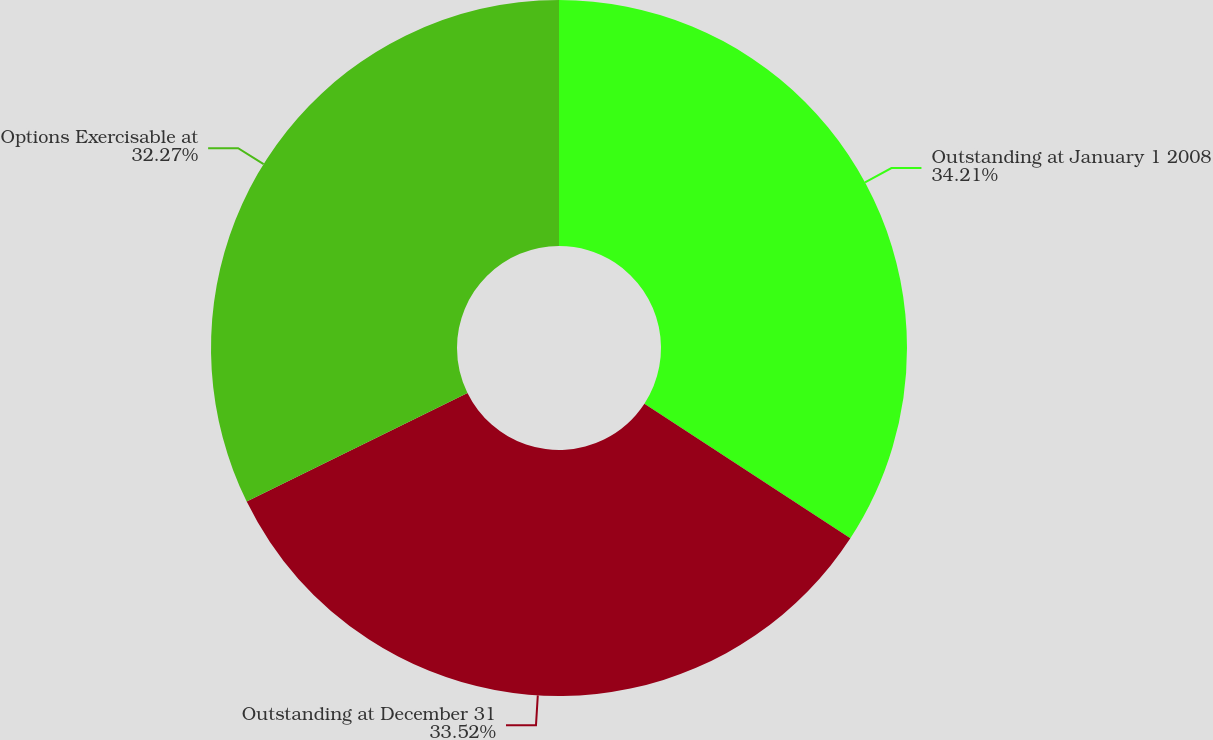Convert chart. <chart><loc_0><loc_0><loc_500><loc_500><pie_chart><fcel>Outstanding at January 1 2008<fcel>Outstanding at December 31<fcel>Options Exercisable at<nl><fcel>34.21%<fcel>33.52%<fcel>32.27%<nl></chart> 